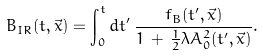<formula> <loc_0><loc_0><loc_500><loc_500>B _ { I R } ( t , \vec { x } ) = \int _ { 0 } ^ { t } d t ^ { \prime } \, \frac { f _ { B } ( t ^ { \prime } , \vec { x } ) } { 1 \, + \, \frac { 1 } { 2 } \lambda A ^ { 2 } _ { 0 } ( t ^ { \prime } , \vec { x } ) } .</formula> 